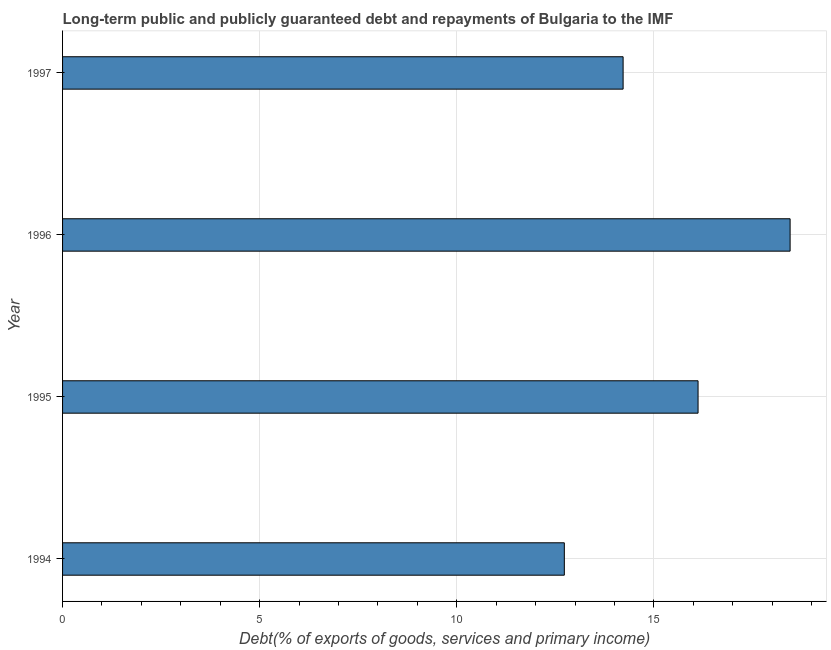Does the graph contain any zero values?
Make the answer very short. No. What is the title of the graph?
Provide a succinct answer. Long-term public and publicly guaranteed debt and repayments of Bulgaria to the IMF. What is the label or title of the X-axis?
Give a very brief answer. Debt(% of exports of goods, services and primary income). What is the debt service in 1994?
Your response must be concise. 12.73. Across all years, what is the maximum debt service?
Offer a very short reply. 18.45. Across all years, what is the minimum debt service?
Give a very brief answer. 12.73. In which year was the debt service maximum?
Make the answer very short. 1996. In which year was the debt service minimum?
Offer a terse response. 1994. What is the sum of the debt service?
Keep it short and to the point. 61.52. What is the difference between the debt service in 1996 and 1997?
Your answer should be very brief. 4.24. What is the average debt service per year?
Your answer should be very brief. 15.38. What is the median debt service?
Provide a short and direct response. 15.17. In how many years, is the debt service greater than 9 %?
Ensure brevity in your answer.  4. What is the ratio of the debt service in 1994 to that in 1995?
Your answer should be compact. 0.79. What is the difference between the highest and the second highest debt service?
Make the answer very short. 2.33. Is the sum of the debt service in 1994 and 1995 greater than the maximum debt service across all years?
Offer a terse response. Yes. What is the difference between the highest and the lowest debt service?
Keep it short and to the point. 5.73. In how many years, is the debt service greater than the average debt service taken over all years?
Ensure brevity in your answer.  2. How many bars are there?
Keep it short and to the point. 4. Are all the bars in the graph horizontal?
Provide a succinct answer. Yes. How many years are there in the graph?
Your response must be concise. 4. What is the difference between two consecutive major ticks on the X-axis?
Your answer should be compact. 5. What is the Debt(% of exports of goods, services and primary income) of 1994?
Give a very brief answer. 12.73. What is the Debt(% of exports of goods, services and primary income) of 1995?
Your response must be concise. 16.12. What is the Debt(% of exports of goods, services and primary income) in 1996?
Offer a very short reply. 18.45. What is the Debt(% of exports of goods, services and primary income) in 1997?
Your response must be concise. 14.22. What is the difference between the Debt(% of exports of goods, services and primary income) in 1994 and 1995?
Offer a terse response. -3.39. What is the difference between the Debt(% of exports of goods, services and primary income) in 1994 and 1996?
Provide a short and direct response. -5.73. What is the difference between the Debt(% of exports of goods, services and primary income) in 1994 and 1997?
Offer a terse response. -1.49. What is the difference between the Debt(% of exports of goods, services and primary income) in 1995 and 1996?
Keep it short and to the point. -2.34. What is the difference between the Debt(% of exports of goods, services and primary income) in 1995 and 1997?
Give a very brief answer. 1.9. What is the difference between the Debt(% of exports of goods, services and primary income) in 1996 and 1997?
Offer a very short reply. 4.24. What is the ratio of the Debt(% of exports of goods, services and primary income) in 1994 to that in 1995?
Your answer should be very brief. 0.79. What is the ratio of the Debt(% of exports of goods, services and primary income) in 1994 to that in 1996?
Your response must be concise. 0.69. What is the ratio of the Debt(% of exports of goods, services and primary income) in 1994 to that in 1997?
Make the answer very short. 0.9. What is the ratio of the Debt(% of exports of goods, services and primary income) in 1995 to that in 1996?
Offer a terse response. 0.87. What is the ratio of the Debt(% of exports of goods, services and primary income) in 1995 to that in 1997?
Your answer should be very brief. 1.13. What is the ratio of the Debt(% of exports of goods, services and primary income) in 1996 to that in 1997?
Ensure brevity in your answer.  1.3. 